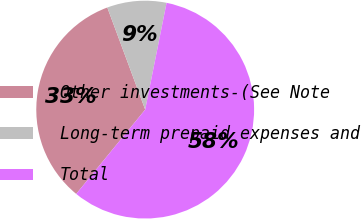Convert chart. <chart><loc_0><loc_0><loc_500><loc_500><pie_chart><fcel>Other investments-(See Note<fcel>Long-term prepaid expenses and<fcel>Total<nl><fcel>33.43%<fcel>8.8%<fcel>57.77%<nl></chart> 